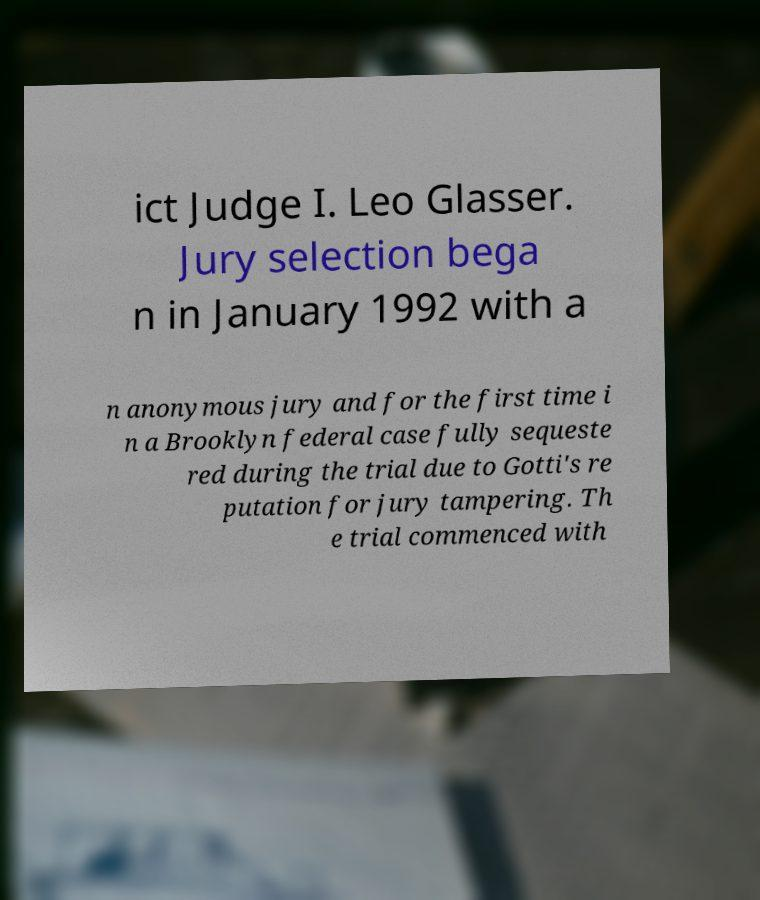What messages or text are displayed in this image? I need them in a readable, typed format. ict Judge I. Leo Glasser. Jury selection bega n in January 1992 with a n anonymous jury and for the first time i n a Brooklyn federal case fully sequeste red during the trial due to Gotti's re putation for jury tampering. Th e trial commenced with 